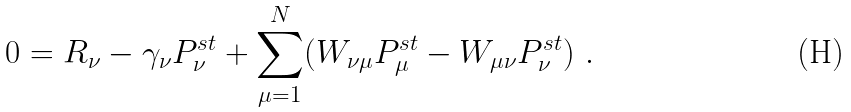Convert formula to latex. <formula><loc_0><loc_0><loc_500><loc_500>0 = R _ { \nu } - \gamma _ { \nu } P _ { \nu } ^ { s t } + \sum _ { \mu = 1 } ^ { N } ( W _ { \nu \mu } P _ { \mu } ^ { s t } - W _ { \mu \nu } P _ { \nu } ^ { s t } ) \ .</formula> 